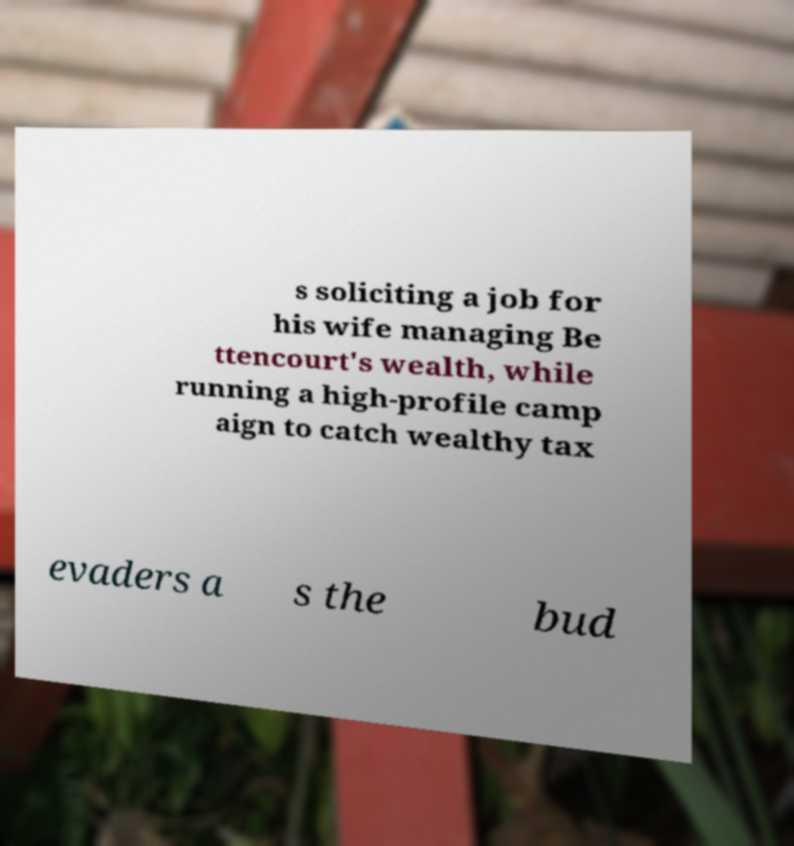Could you assist in decoding the text presented in this image and type it out clearly? s soliciting a job for his wife managing Be ttencourt's wealth, while running a high-profile camp aign to catch wealthy tax evaders a s the bud 